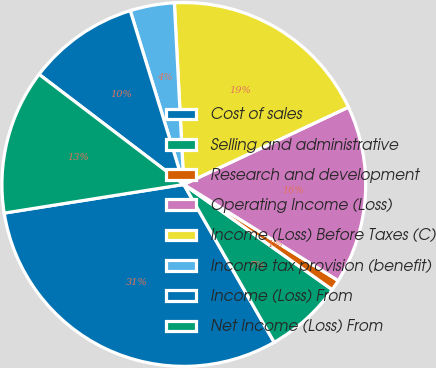Convert chart to OTSL. <chart><loc_0><loc_0><loc_500><loc_500><pie_chart><fcel>Cost of sales<fcel>Selling and administrative<fcel>Research and development<fcel>Operating Income (Loss)<fcel>Income (Loss) Before Taxes (C)<fcel>Income tax provision (benefit)<fcel>Income (Loss) From<fcel>Net Income (Loss) From<nl><fcel>30.76%<fcel>6.91%<fcel>0.95%<fcel>15.85%<fcel>18.84%<fcel>3.93%<fcel>9.89%<fcel>12.87%<nl></chart> 